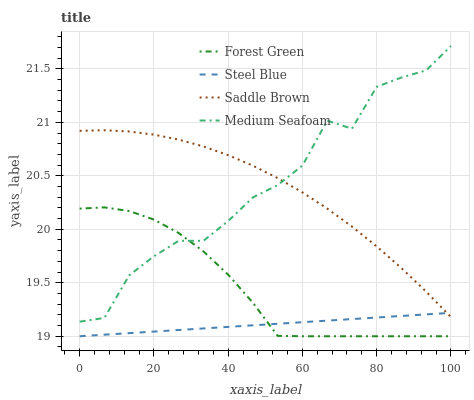Does Steel Blue have the minimum area under the curve?
Answer yes or no. Yes. Does Medium Seafoam have the maximum area under the curve?
Answer yes or no. Yes. Does Medium Seafoam have the minimum area under the curve?
Answer yes or no. No. Does Steel Blue have the maximum area under the curve?
Answer yes or no. No. Is Steel Blue the smoothest?
Answer yes or no. Yes. Is Medium Seafoam the roughest?
Answer yes or no. Yes. Is Medium Seafoam the smoothest?
Answer yes or no. No. Is Steel Blue the roughest?
Answer yes or no. No. Does Forest Green have the lowest value?
Answer yes or no. Yes. Does Medium Seafoam have the lowest value?
Answer yes or no. No. Does Medium Seafoam have the highest value?
Answer yes or no. Yes. Does Steel Blue have the highest value?
Answer yes or no. No. Is Forest Green less than Saddle Brown?
Answer yes or no. Yes. Is Saddle Brown greater than Forest Green?
Answer yes or no. Yes. Does Steel Blue intersect Forest Green?
Answer yes or no. Yes. Is Steel Blue less than Forest Green?
Answer yes or no. No. Is Steel Blue greater than Forest Green?
Answer yes or no. No. Does Forest Green intersect Saddle Brown?
Answer yes or no. No. 